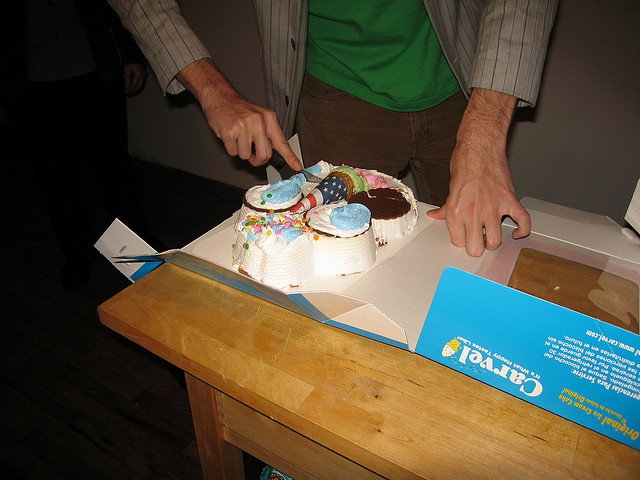Describe the objects in this image and their specific colors. I can see dining table in black, olive, lightblue, tan, and ivory tones, people in black, darkgreen, brown, and gray tones, people in black, darkgray, and gray tones, cake in black, ivory, and tan tones, and knife in black, gray, maroon, and darkgreen tones in this image. 